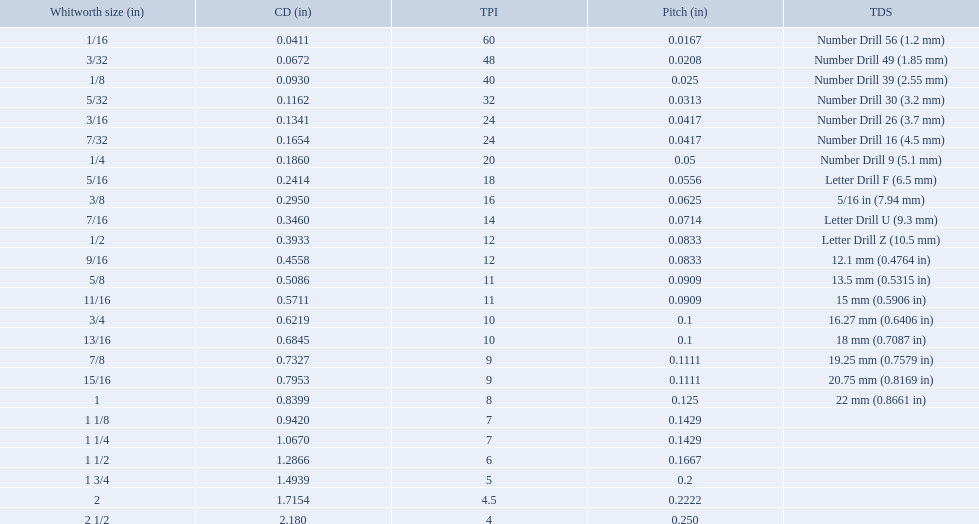A 1/16 whitworth has a core diameter of? 0.0411. Which whiteworth size has the same pitch as a 1/2? 9/16. 3/16 whiteworth has the same number of threads as? 7/32. What is the core diameter for the number drill 26? 0.1341. What is the whitworth size (in) for this core diameter? 3/16. 